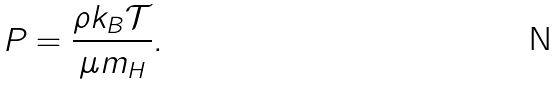Convert formula to latex. <formula><loc_0><loc_0><loc_500><loc_500>P = \frac { \rho k _ { B } \mathcal { T } } { \mu m _ { H } } .</formula> 